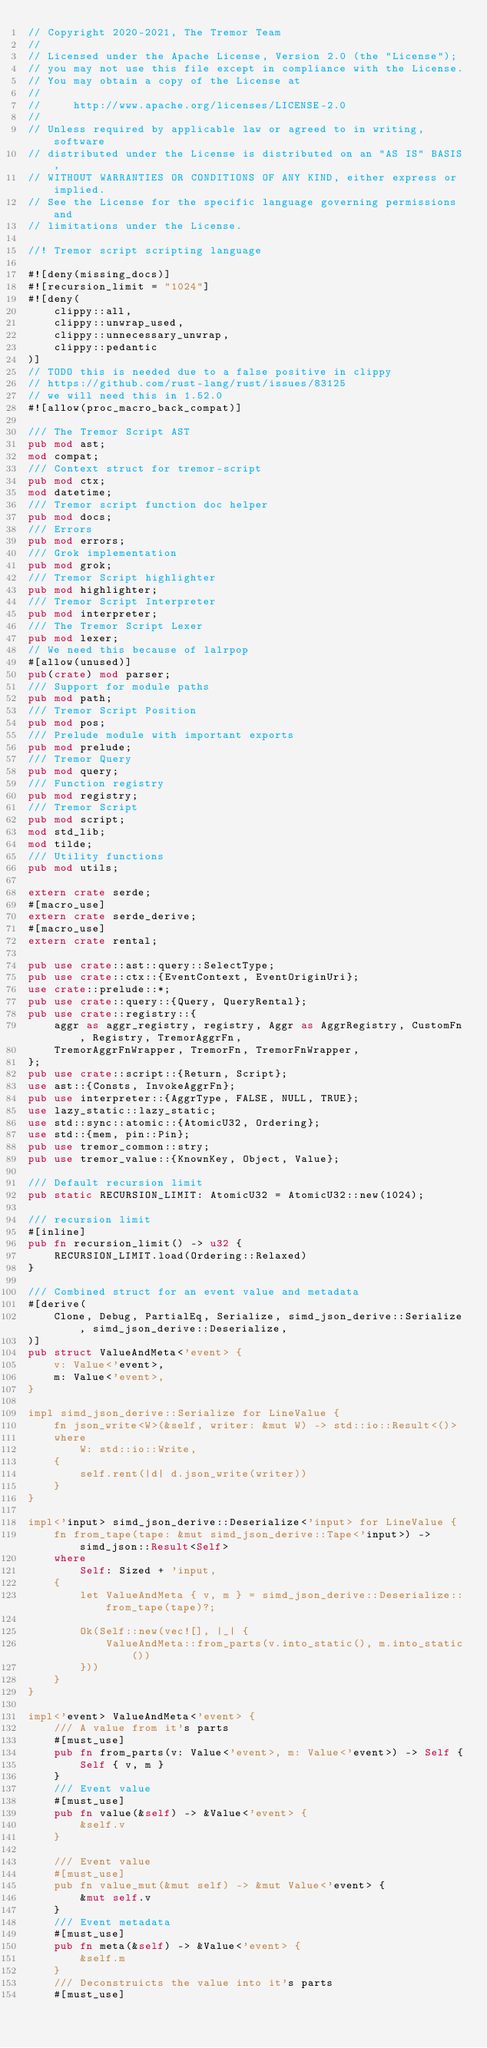Convert code to text. <code><loc_0><loc_0><loc_500><loc_500><_Rust_>// Copyright 2020-2021, The Tremor Team
//
// Licensed under the Apache License, Version 2.0 (the "License");
// you may not use this file except in compliance with the License.
// You may obtain a copy of the License at
//
//     http://www.apache.org/licenses/LICENSE-2.0
//
// Unless required by applicable law or agreed to in writing, software
// distributed under the License is distributed on an "AS IS" BASIS,
// WITHOUT WARRANTIES OR CONDITIONS OF ANY KIND, either express or implied.
// See the License for the specific language governing permissions and
// limitations under the License.

//! Tremor script scripting language

#![deny(missing_docs)]
#![recursion_limit = "1024"]
#![deny(
    clippy::all,
    clippy::unwrap_used,
    clippy::unnecessary_unwrap,
    clippy::pedantic
)]
// TODO this is needed due to a false positive in clippy
// https://github.com/rust-lang/rust/issues/83125
// we will need this in 1.52.0
#![allow(proc_macro_back_compat)]

/// The Tremor Script AST
pub mod ast;
mod compat;
/// Context struct for tremor-script
pub mod ctx;
mod datetime;
/// Tremor script function doc helper
pub mod docs;
/// Errors
pub mod errors;
/// Grok implementation
pub mod grok;
/// Tremor Script highlighter
pub mod highlighter;
/// Tremor Script Interpreter
pub mod interpreter;
/// The Tremor Script Lexer
pub mod lexer;
// We need this because of lalrpop
#[allow(unused)]
pub(crate) mod parser;
/// Support for module paths
pub mod path;
/// Tremor Script Position
pub mod pos;
/// Prelude module with important exports
pub mod prelude;
/// Tremor Query
pub mod query;
/// Function registry
pub mod registry;
/// Tremor Script
pub mod script;
mod std_lib;
mod tilde;
/// Utility functions
pub mod utils;

extern crate serde;
#[macro_use]
extern crate serde_derive;
#[macro_use]
extern crate rental;

pub use crate::ast::query::SelectType;
pub use crate::ctx::{EventContext, EventOriginUri};
use crate::prelude::*;
pub use crate::query::{Query, QueryRental};
pub use crate::registry::{
    aggr as aggr_registry, registry, Aggr as AggrRegistry, CustomFn, Registry, TremorAggrFn,
    TremorAggrFnWrapper, TremorFn, TremorFnWrapper,
};
pub use crate::script::{Return, Script};
use ast::{Consts, InvokeAggrFn};
pub use interpreter::{AggrType, FALSE, NULL, TRUE};
use lazy_static::lazy_static;
use std::sync::atomic::{AtomicU32, Ordering};
use std::{mem, pin::Pin};
pub use tremor_common::stry;
pub use tremor_value::{KnownKey, Object, Value};

/// Default recursion limit
pub static RECURSION_LIMIT: AtomicU32 = AtomicU32::new(1024);

/// recursion limit
#[inline]
pub fn recursion_limit() -> u32 {
    RECURSION_LIMIT.load(Ordering::Relaxed)
}

/// Combined struct for an event value and metadata
#[derive(
    Clone, Debug, PartialEq, Serialize, simd_json_derive::Serialize, simd_json_derive::Deserialize,
)]
pub struct ValueAndMeta<'event> {
    v: Value<'event>,
    m: Value<'event>,
}

impl simd_json_derive::Serialize for LineValue {
    fn json_write<W>(&self, writer: &mut W) -> std::io::Result<()>
    where
        W: std::io::Write,
    {
        self.rent(|d| d.json_write(writer))
    }
}

impl<'input> simd_json_derive::Deserialize<'input> for LineValue {
    fn from_tape(tape: &mut simd_json_derive::Tape<'input>) -> simd_json::Result<Self>
    where
        Self: Sized + 'input,
    {
        let ValueAndMeta { v, m } = simd_json_derive::Deserialize::from_tape(tape)?;

        Ok(Self::new(vec![], |_| {
            ValueAndMeta::from_parts(v.into_static(), m.into_static())
        }))
    }
}

impl<'event> ValueAndMeta<'event> {
    /// A value from it's parts
    #[must_use]
    pub fn from_parts(v: Value<'event>, m: Value<'event>) -> Self {
        Self { v, m }
    }
    /// Event value
    #[must_use]
    pub fn value(&self) -> &Value<'event> {
        &self.v
    }

    /// Event value
    #[must_use]
    pub fn value_mut(&mut self) -> &mut Value<'event> {
        &mut self.v
    }
    /// Event metadata
    #[must_use]
    pub fn meta(&self) -> &Value<'event> {
        &self.m
    }
    /// Deconstruicts the value into it's parts
    #[must_use]</code> 